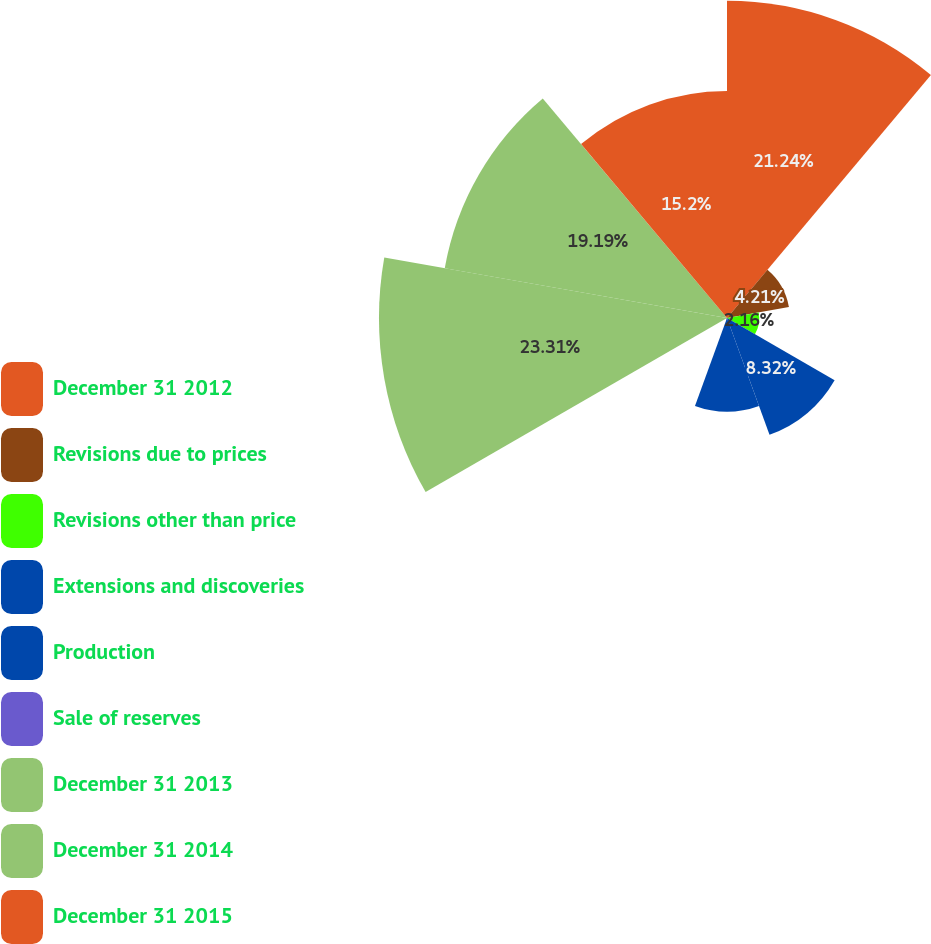<chart> <loc_0><loc_0><loc_500><loc_500><pie_chart><fcel>December 31 2012<fcel>Revisions due to prices<fcel>Revisions other than price<fcel>Extensions and discoveries<fcel>Production<fcel>Sale of reserves<fcel>December 31 2013<fcel>December 31 2014<fcel>December 31 2015<nl><fcel>21.24%<fcel>4.21%<fcel>2.16%<fcel>8.32%<fcel>6.27%<fcel>0.1%<fcel>23.3%<fcel>19.19%<fcel>15.2%<nl></chart> 